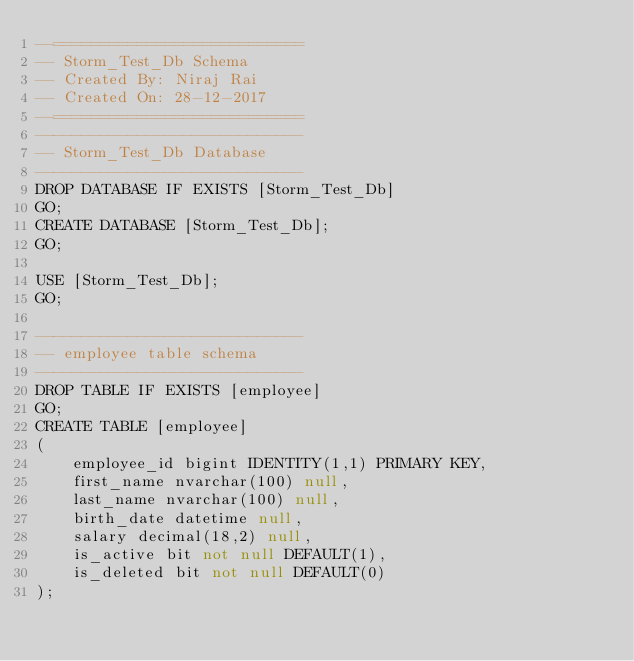<code> <loc_0><loc_0><loc_500><loc_500><_SQL_>--===========================
-- Storm_Test_Db Schema
-- Created By: Niraj Rai
-- Created On: 28-12-2017
--=========================== 
-----------------------------
-- Storm_Test_Db Database
-----------------------------
DROP DATABASE IF EXISTS [Storm_Test_Db]
GO;
CREATE DATABASE [Storm_Test_Db];
GO;

USE [Storm_Test_Db];
GO;

-----------------------------
-- employee table schema
-----------------------------
DROP TABLE IF EXISTS [employee]
GO;
CREATE TABLE [employee]
(
    employee_id bigint IDENTITY(1,1) PRIMARY KEY,
    first_name nvarchar(100) null,
    last_name nvarchar(100) null,
    birth_date datetime null,
    salary decimal(18,2) null,
    is_active bit not null DEFAULT(1),
    is_deleted bit not null DEFAULT(0)    
);


</code> 